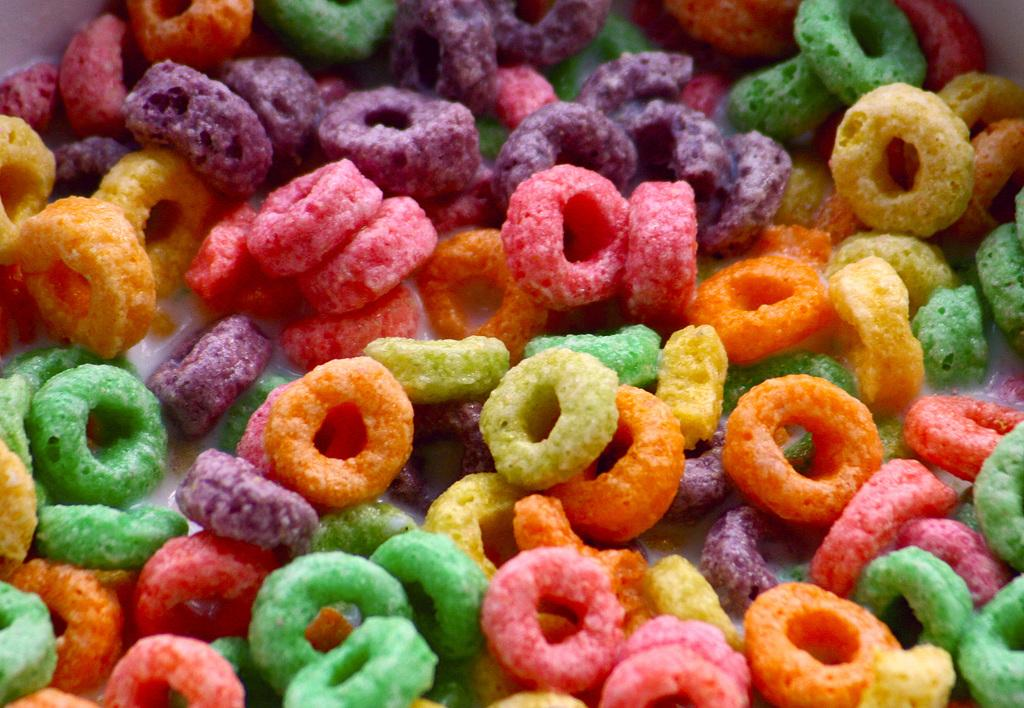What type of food is depicted in the image? There are fruit loops in the image. Can you describe the colors of the fruit loops? The fruit loops are in different colors: green, orange, pink, violet, and yellow. What type of oatmeal is being served to the army in the image? There is no army or oatmeal present in the image; it only features fruit loops in different colors. Can you identify the animal that is eating the fruit loops in the image? There is no animal present in the image; it only features fruit loops in different colors. 